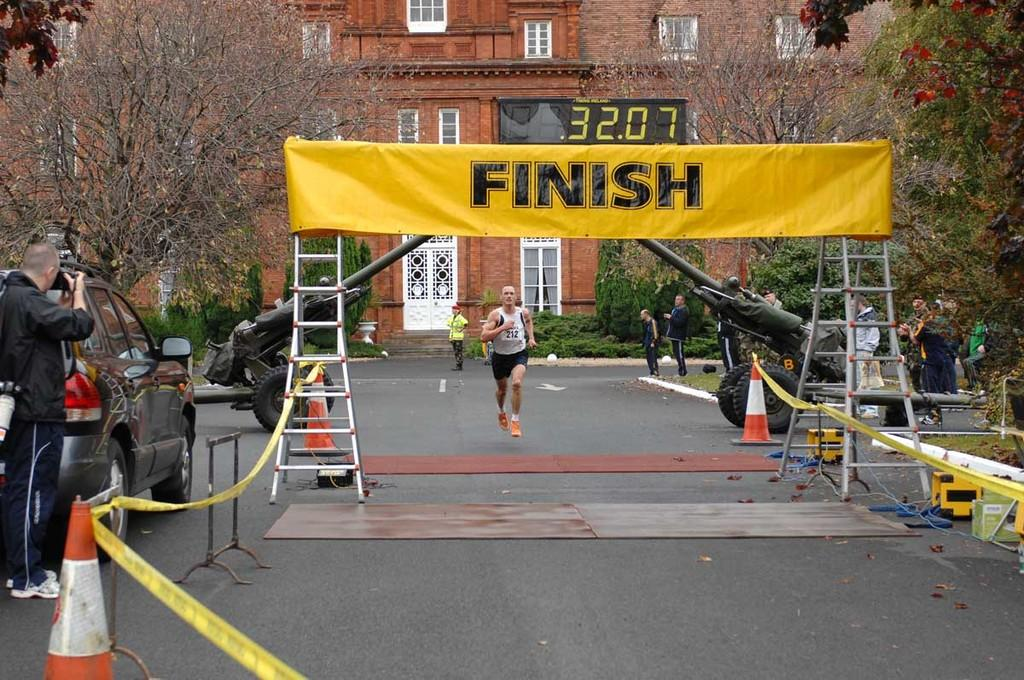<image>
Describe the image concisely. A bright yellow finish line sign with a clock reading 32.07 over it. 